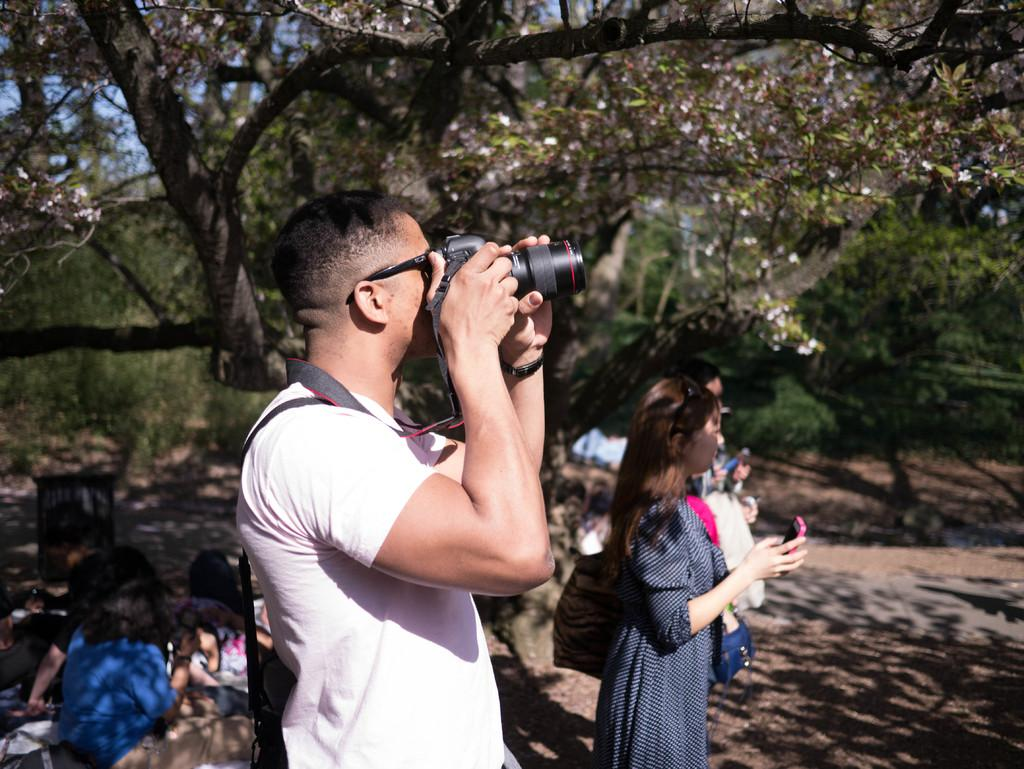What is the main feature of the image? There is a road in the image. What else can be seen in the image besides the road? There are trees, people standing, and people sitting on the ground in the image. Can you describe the person holding a camera? A man is standing and holding a camera, and he is taking pictures. What type of waves can be seen crashing on the shore in the image? There are no waves or shore present in the image; it features a road, trees, and people. 